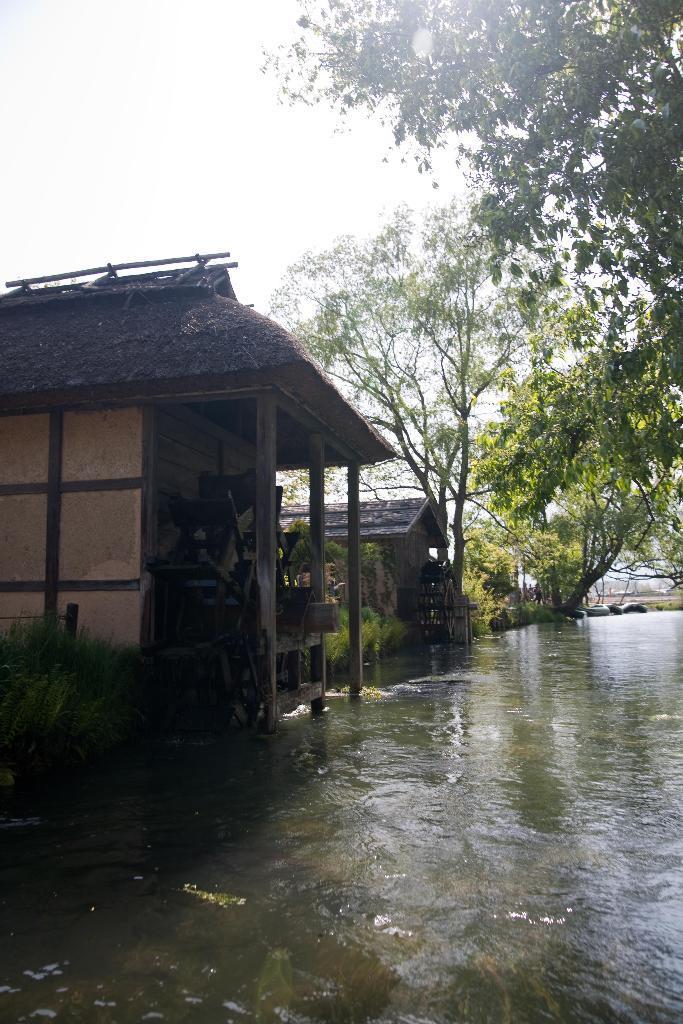Describe this image in one or two sentences. In this image I can see the water. To the side of the water I can see many trees and the houses. In the background I can see the sky. 